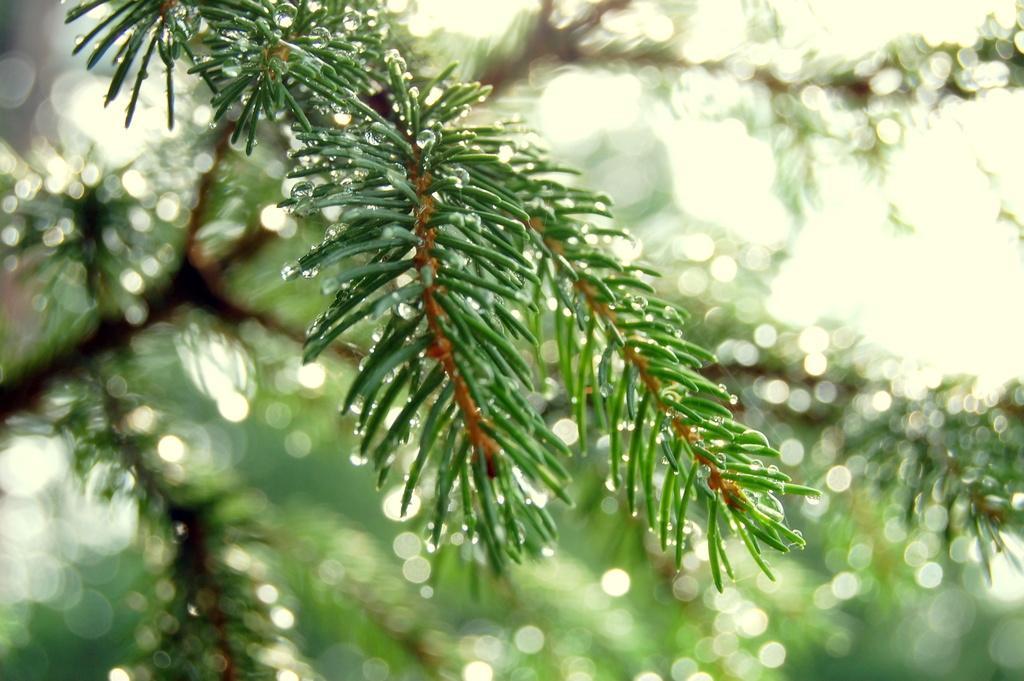How would you summarize this image in a sentence or two? In this image we can see a tree with water droplets. The background of the image is slightly blurred. 